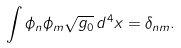Convert formula to latex. <formula><loc_0><loc_0><loc_500><loc_500>\int \phi _ { n } \phi _ { m } \sqrt { g _ { 0 } } \, d ^ { 4 } x = \delta _ { n m } .</formula> 